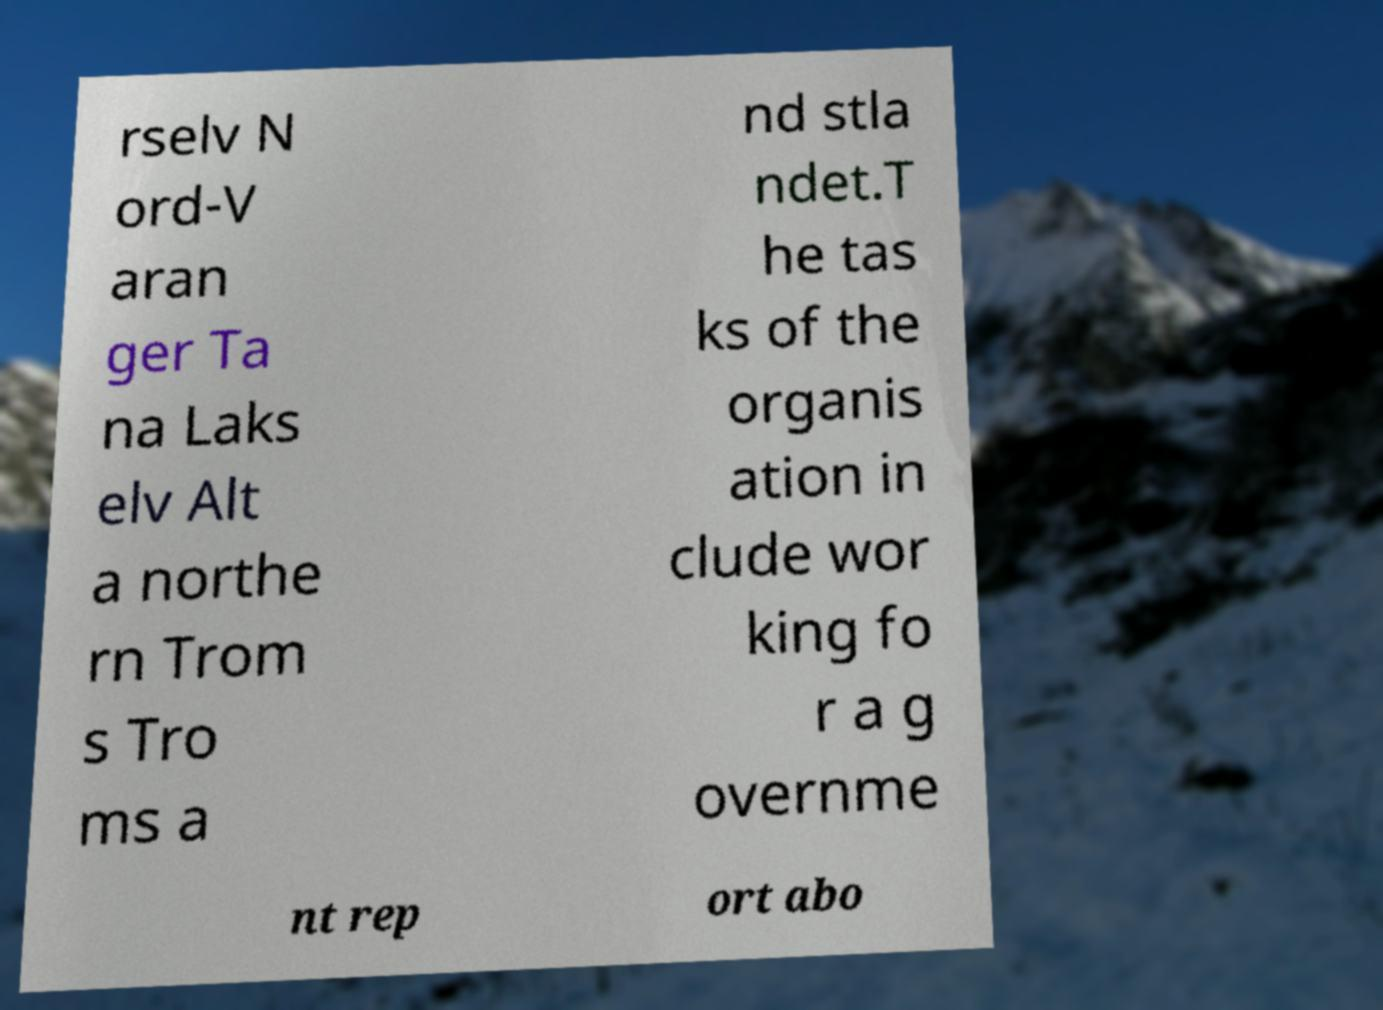I need the written content from this picture converted into text. Can you do that? rselv N ord-V aran ger Ta na Laks elv Alt a northe rn Trom s Tro ms a nd stla ndet.T he tas ks of the organis ation in clude wor king fo r a g overnme nt rep ort abo 